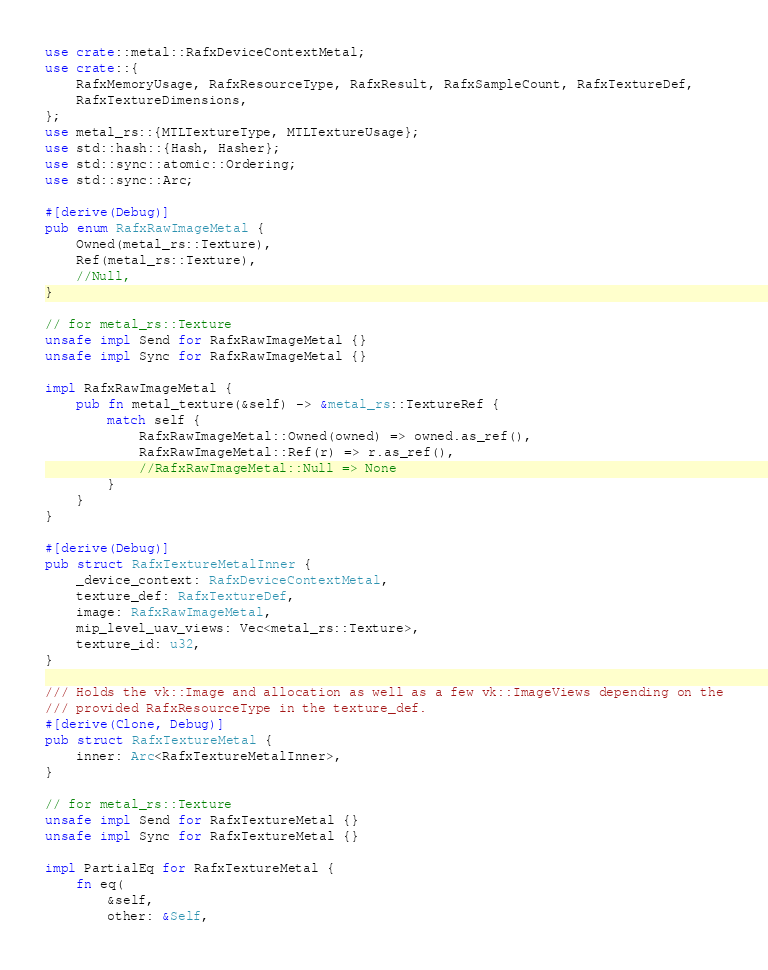Convert code to text. <code><loc_0><loc_0><loc_500><loc_500><_Rust_>use crate::metal::RafxDeviceContextMetal;
use crate::{
    RafxMemoryUsage, RafxResourceType, RafxResult, RafxSampleCount, RafxTextureDef,
    RafxTextureDimensions,
};
use metal_rs::{MTLTextureType, MTLTextureUsage};
use std::hash::{Hash, Hasher};
use std::sync::atomic::Ordering;
use std::sync::Arc;

#[derive(Debug)]
pub enum RafxRawImageMetal {
    Owned(metal_rs::Texture),
    Ref(metal_rs::Texture),
    //Null,
}

// for metal_rs::Texture
unsafe impl Send for RafxRawImageMetal {}
unsafe impl Sync for RafxRawImageMetal {}

impl RafxRawImageMetal {
    pub fn metal_texture(&self) -> &metal_rs::TextureRef {
        match self {
            RafxRawImageMetal::Owned(owned) => owned.as_ref(),
            RafxRawImageMetal::Ref(r) => r.as_ref(),
            //RafxRawImageMetal::Null => None
        }
    }
}

#[derive(Debug)]
pub struct RafxTextureMetalInner {
    _device_context: RafxDeviceContextMetal,
    texture_def: RafxTextureDef,
    image: RafxRawImageMetal,
    mip_level_uav_views: Vec<metal_rs::Texture>,
    texture_id: u32,
}

/// Holds the vk::Image and allocation as well as a few vk::ImageViews depending on the
/// provided RafxResourceType in the texture_def.
#[derive(Clone, Debug)]
pub struct RafxTextureMetal {
    inner: Arc<RafxTextureMetalInner>,
}

// for metal_rs::Texture
unsafe impl Send for RafxTextureMetal {}
unsafe impl Sync for RafxTextureMetal {}

impl PartialEq for RafxTextureMetal {
    fn eq(
        &self,
        other: &Self,</code> 